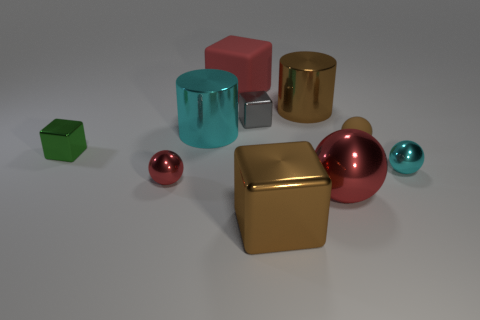How many other objects are the same material as the tiny green object?
Your response must be concise. 7. Is the size of the cyan cylinder the same as the brown object that is in front of the tiny green block?
Ensure brevity in your answer.  Yes. The large matte thing is what color?
Give a very brief answer. Red. What shape is the small rubber thing in front of the big cylinder that is on the left side of the brown shiny object to the left of the large brown shiny cylinder?
Your answer should be compact. Sphere. The large red object that is behind the red metallic ball that is left of the brown metallic cube is made of what material?
Make the answer very short. Rubber. What is the shape of the brown thing that is made of the same material as the red block?
Provide a succinct answer. Sphere. Is there any other thing that is the same shape as the large red rubber thing?
Provide a short and direct response. Yes. There is a big matte cube; what number of big red things are to the left of it?
Make the answer very short. 0. Is there a tiny green rubber sphere?
Your response must be concise. No. What is the color of the cube that is in front of the cyan object that is to the right of the metallic cylinder that is behind the gray cube?
Your answer should be compact. Brown. 